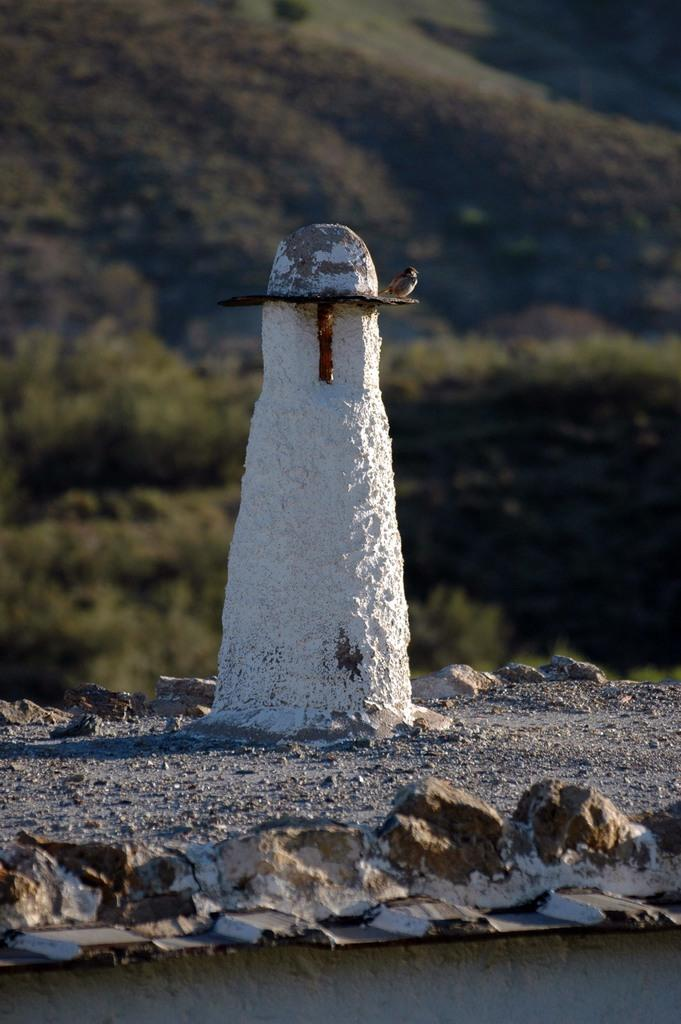What is the main object in the image? There is a stone in the image. What other living creature can be seen in the image? There is a bird in the image. What type of vegetation is visible in the background? There are trees in the background of the image. How would you describe the background of the image? The background is blurry. What type of zinc is being used to tie the string around the stone in the image? There is no zinc or string present in the image. 